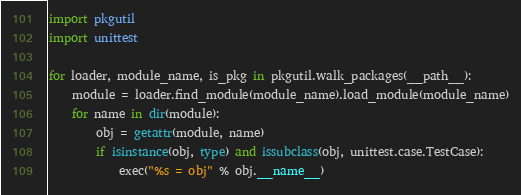<code> <loc_0><loc_0><loc_500><loc_500><_Python_>import pkgutil
import unittest

for loader, module_name, is_pkg in pkgutil.walk_packages(__path__):
    module = loader.find_module(module_name).load_module(module_name)
    for name in dir(module):
        obj = getattr(module, name)
        if isinstance(obj, type) and issubclass(obj, unittest.case.TestCase):
            exec("%s = obj" % obj.__name__)
</code> 